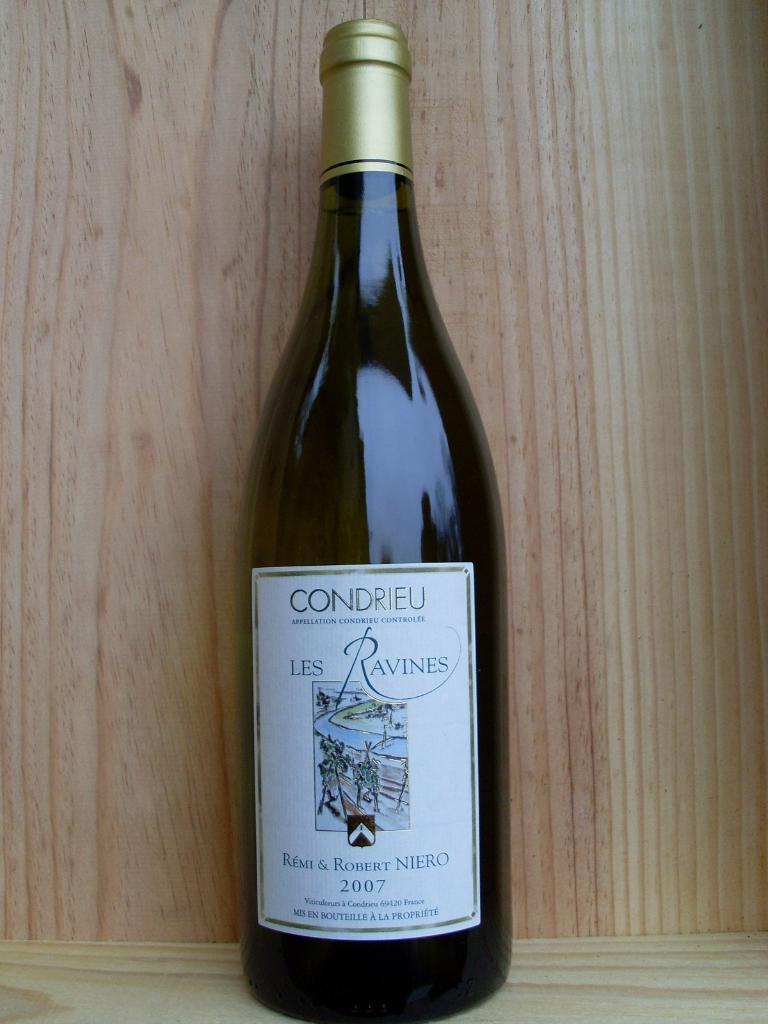Provide a one-sentence caption for the provided image. An unopened bottle of Les Ravines dated 2007. 